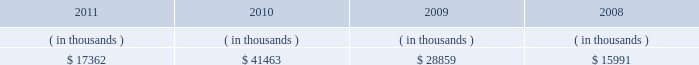Entergy arkansas , inc .
And subsidiaries management 2019s financial discussion and analysis entergy arkansas 2019s receivables from the money pool were as follows as of december 31 for each of the following years: .
In april 2011 , entergy arkansas entered into a new $ 78 million credit facility that expires in april 2012 .
There were no outstanding borrowings under the entergy arkansas credit facility as of december 31 , 2011 .
Entergy arkansas has obtained short-term borrowing authorization from the ferc under which it may borrow through october 2013 , up to the aggregate amount , at any one time outstanding , of $ 250 million .
See note 4 to the financial statements for further discussion of entergy arkansas 2019s short-term borrowing limits .
Entergy arkansas has also obtained an order from the apsc authorizing long-term securities issuances through december state and local rate regulation and fuel-cost recovery retail rates 2009 base rate filing in september 2009 , entergy arkansas filed with the apsc for a general change in rates , charges , and tariffs .
In june 2010 the apsc approved a settlement and subsequent compliance tariffs that provide for a $ 63.7 million rate increase , effective for bills rendered for the first billing cycle of july 2010 .
The settlement provides for a 10.2% ( 10.2 % ) return on common equity .
Production cost allocation rider the apsc approved a production cost allocation rider for recovery from customers of the retail portion of the costs allocated to entergy arkansas as a result of the system agreement proceedings .
These costs cause an increase in entergy arkansas 2019s deferred fuel cost balance , because entergy arkansas pays the costs over seven months but collects them from customers over twelve months .
See note 2 to the financial statements and entergy corporation and subsidiaries 201cmanagement 2019s financial discussion and analysis - system agreement 201d for discussions of the system agreement proceedings .
Energy cost recovery rider entergy arkansas 2019s retail rates include an energy cost recovery rider to recover fuel and purchased energy costs in monthly bills .
The rider utilizes prior calendar year energy costs and projected energy sales for the twelve- month period commencing on april 1 of each year to develop an energy cost rate , which is redetermined annually and includes a true-up adjustment reflecting the over-recovery or under-recovery , including carrying charges , of the energy cost for the prior calendar year .
The energy cost recovery rider tariff also allows an interim rate request depending upon the level of over- or under-recovery of fuel and purchased energy costs .
In early october 2005 , the apsc initiated an investigation into entergy arkansas's interim energy cost recovery rate .
The investigation focused on entergy arkansas's 1 ) gas contracting , portfolio , and hedging practices ; 2 ) wholesale purchases during the period ; 3 ) management of the coal inventory at its coal generation plants ; and 4 ) response to the contractual failure of the railroads to provide coal deliveries .
In march 2006 , the apsc extended its investigation to cover the costs included in entergy arkansas's march 2006 annual energy cost rate filing , and a hearing was held in the apsc energy cost recovery investigation in october 2006. .
What was the percent of the new entergy arkansas credit facility to the accounts receivables in 2011? 
Computations: (78 / 17362)
Answer: 0.00449. 